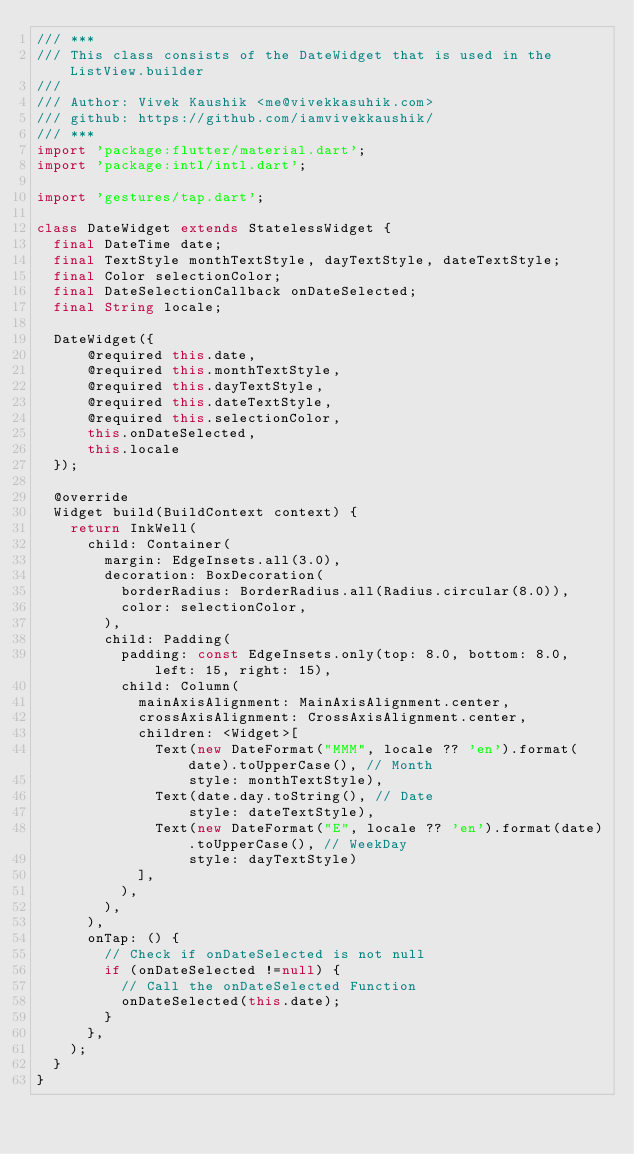<code> <loc_0><loc_0><loc_500><loc_500><_Dart_>/// ***
/// This class consists of the DateWidget that is used in the ListView.builder
///
/// Author: Vivek Kaushik <me@vivekkasuhik.com>
/// github: https://github.com/iamvivekkaushik/
/// ***
import 'package:flutter/material.dart';
import 'package:intl/intl.dart';

import 'gestures/tap.dart';

class DateWidget extends StatelessWidget {
  final DateTime date;
  final TextStyle monthTextStyle, dayTextStyle, dateTextStyle;
  final Color selectionColor;
  final DateSelectionCallback onDateSelected;
  final String locale;

  DateWidget({
      @required this.date,
      @required this.monthTextStyle,
      @required this.dayTextStyle,
      @required this.dateTextStyle,
      @required this.selectionColor,
      this.onDateSelected,
      this.locale
  });

  @override
  Widget build(BuildContext context) {
    return InkWell(
      child: Container(
        margin: EdgeInsets.all(3.0),
        decoration: BoxDecoration(
          borderRadius: BorderRadius.all(Radius.circular(8.0)),
          color: selectionColor,
        ),
        child: Padding(
          padding: const EdgeInsets.only(top: 8.0, bottom: 8.0, left: 15, right: 15),
          child: Column(
            mainAxisAlignment: MainAxisAlignment.center,
            crossAxisAlignment: CrossAxisAlignment.center,
            children: <Widget>[
              Text(new DateFormat("MMM", locale ?? 'en').format(date).toUpperCase(), // Month
                  style: monthTextStyle),
              Text(date.day.toString(), // Date
                  style: dateTextStyle),
              Text(new DateFormat("E", locale ?? 'en').format(date).toUpperCase(), // WeekDay
                  style: dayTextStyle)
            ],
          ),
        ),
      ),
      onTap: () {
        // Check if onDateSelected is not null
        if (onDateSelected !=null) {
          // Call the onDateSelected Function
          onDateSelected(this.date);
        }
      },
    );
  }
}
</code> 